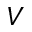<formula> <loc_0><loc_0><loc_500><loc_500>V</formula> 